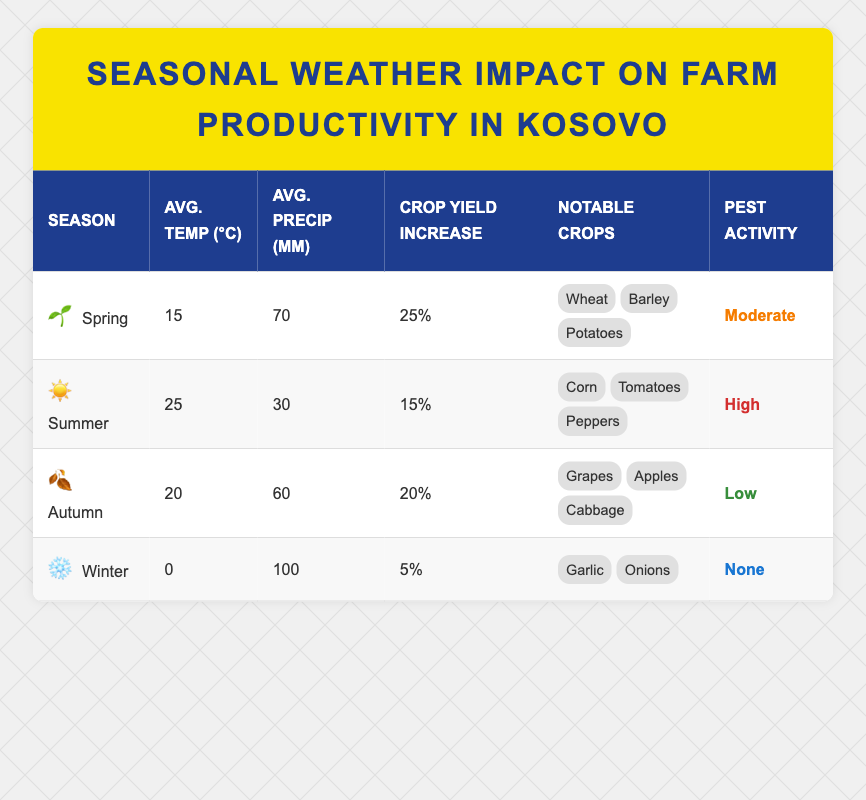What is the average temperature during Spring in Kosovo? The table states that the average temperature during Spring is listed as 15 degrees Celsius.
Answer: 15°C Which season has the highest crop yield increase percentage? By comparing the crop yield increase percentages in the table, Spring has the highest at 25%.
Answer: Spring What notable crops are associated with Summer? The table indicates that the notable crops for Summer are Corn, Tomatoes, and Peppers.
Answer: Corn, Tomatoes, Peppers Is the pest activity level during Autumn low? The table explicitly shows that the pest activity level for Autumn is labeled as Low.
Answer: Yes Which season has the lowest average precipitation? Upon examining the average precipitation values, Summer has the lowest at 30 mm.
Answer: Summer What is the total increase in crop yield percentage from Spring to Autumn? Calculating the increase involves finding the difference in percentages from Spring (25%) to Autumn (20%). The total increase would be 25% - 20% = 5%.
Answer: 5% During which season is pest activity nonexistent? According to the information in the table, the Winter season has a pest activity level marked as None.
Answer: Winter What is the average temperature across all seasons? To find the average temperature, we sum the temperatures (15 + 25 + 20 + 0 = 60) and divide by the number of seasons (4). The average temperature is 60/4 = 15°C.
Answer: 15°C If the summer crops yield an increase of 15%, which season has a higher yield increase: Spring or Summer? By comparing the yield increases, Spring yields 25% while Summer yields only 15%, so Spring has a higher yield increase.
Answer: Spring Which notable crop is associated with Winter? The notable crops listed for Winter in the table are Garlic and Onions.
Answer: Garlic, Onions 